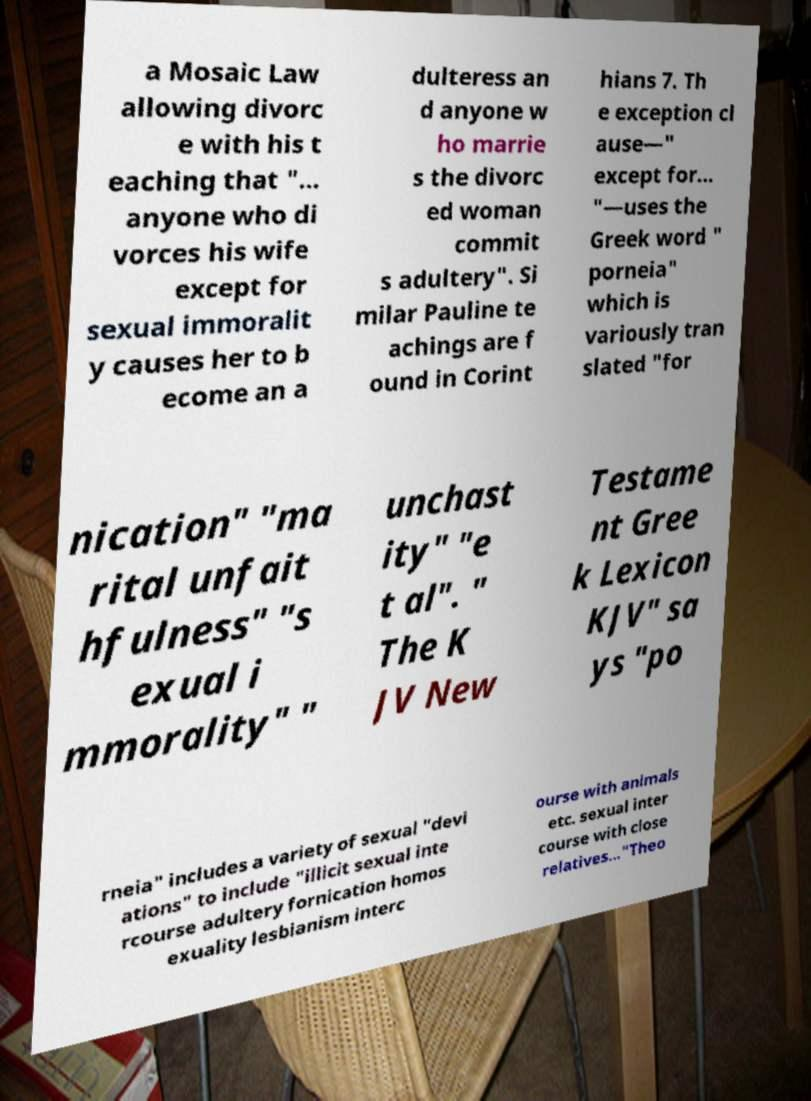Can you accurately transcribe the text from the provided image for me? a Mosaic Law allowing divorc e with his t eaching that "... anyone who di vorces his wife except for sexual immoralit y causes her to b ecome an a dulteress an d anyone w ho marrie s the divorc ed woman commit s adultery". Si milar Pauline te achings are f ound in Corint hians 7. Th e exception cl ause—" except for... "—uses the Greek word " porneia" which is variously tran slated "for nication" "ma rital unfait hfulness" "s exual i mmorality" " unchast ity" "e t al". " The K JV New Testame nt Gree k Lexicon KJV" sa ys "po rneia" includes a variety of sexual "devi ations" to include "illicit sexual inte rcourse adultery fornication homos exuality lesbianism interc ourse with animals etc. sexual inter course with close relatives..."Theo 